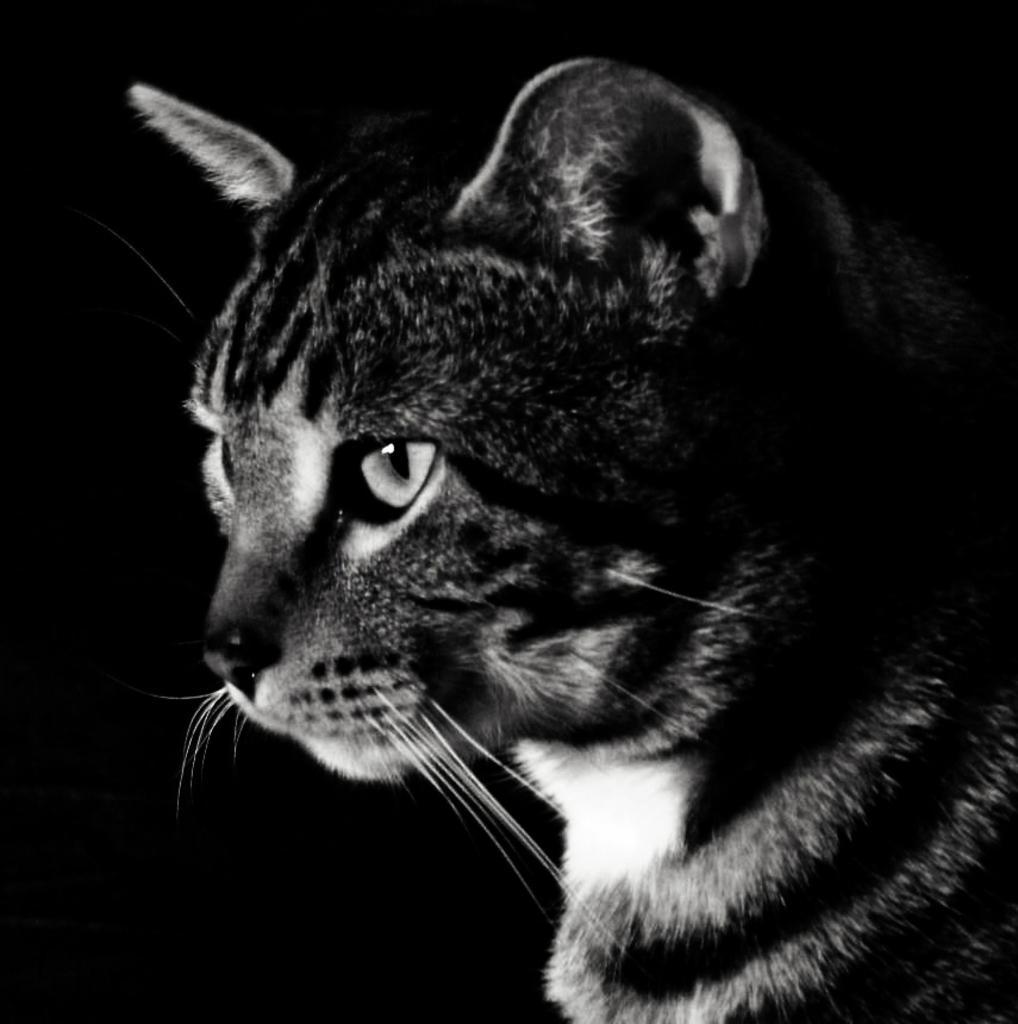Could you give a brief overview of what you see in this image? In this picture there is a cat. At the back there is a black background. 